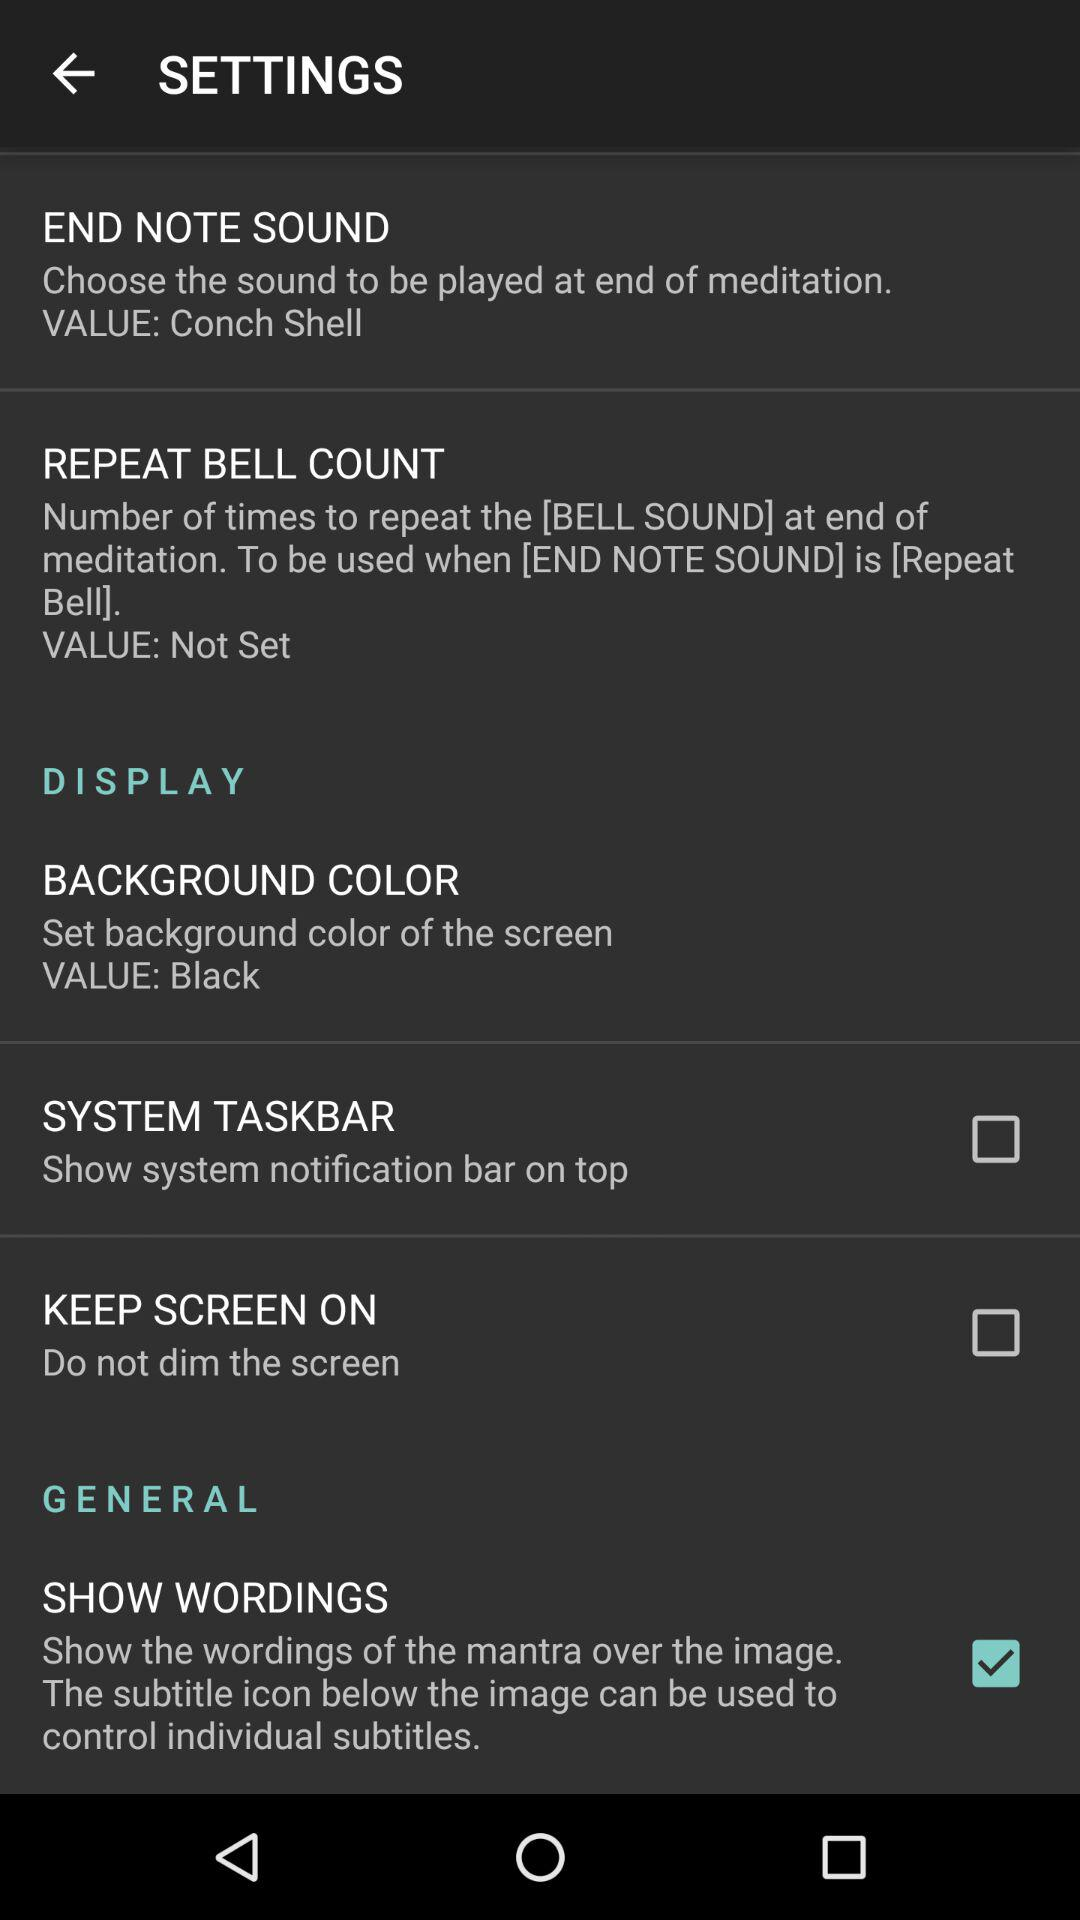How many options are there for the BACKGROUND COLOR setting?
Answer the question using a single word or phrase. 1 